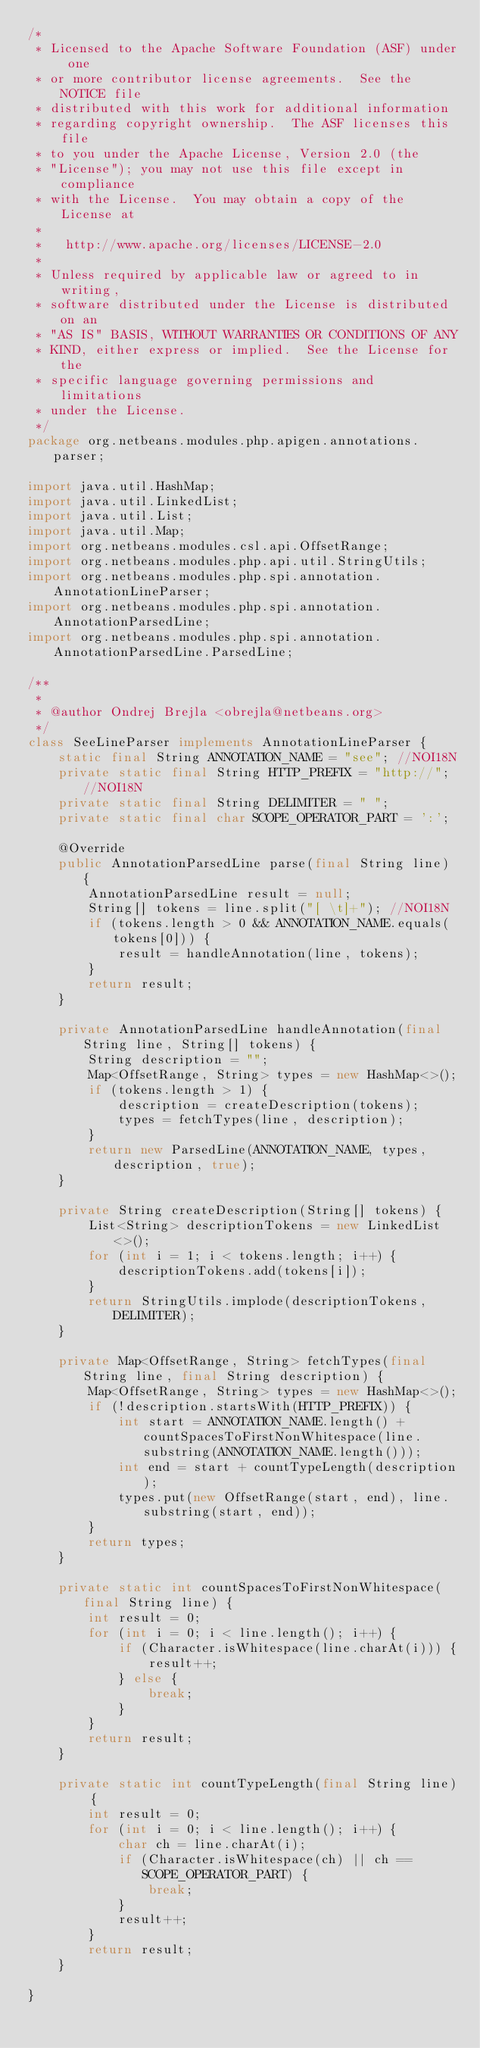<code> <loc_0><loc_0><loc_500><loc_500><_Java_>/*
 * Licensed to the Apache Software Foundation (ASF) under one
 * or more contributor license agreements.  See the NOTICE file
 * distributed with this work for additional information
 * regarding copyright ownership.  The ASF licenses this file
 * to you under the Apache License, Version 2.0 (the
 * "License"); you may not use this file except in compliance
 * with the License.  You may obtain a copy of the License at
 *
 *   http://www.apache.org/licenses/LICENSE-2.0
 *
 * Unless required by applicable law or agreed to in writing,
 * software distributed under the License is distributed on an
 * "AS IS" BASIS, WITHOUT WARRANTIES OR CONDITIONS OF ANY
 * KIND, either express or implied.  See the License for the
 * specific language governing permissions and limitations
 * under the License.
 */
package org.netbeans.modules.php.apigen.annotations.parser;

import java.util.HashMap;
import java.util.LinkedList;
import java.util.List;
import java.util.Map;
import org.netbeans.modules.csl.api.OffsetRange;
import org.netbeans.modules.php.api.util.StringUtils;
import org.netbeans.modules.php.spi.annotation.AnnotationLineParser;
import org.netbeans.modules.php.spi.annotation.AnnotationParsedLine;
import org.netbeans.modules.php.spi.annotation.AnnotationParsedLine.ParsedLine;

/**
 *
 * @author Ondrej Brejla <obrejla@netbeans.org>
 */
class SeeLineParser implements AnnotationLineParser {
    static final String ANNOTATION_NAME = "see"; //NOI18N
    private static final String HTTP_PREFIX = "http://"; //NOI18N
    private static final String DELIMITER = " ";
    private static final char SCOPE_OPERATOR_PART = ':';

    @Override
    public AnnotationParsedLine parse(final String line) {
        AnnotationParsedLine result = null;
        String[] tokens = line.split("[ \t]+"); //NOI18N
        if (tokens.length > 0 && ANNOTATION_NAME.equals(tokens[0])) {
            result = handleAnnotation(line, tokens);
        }
        return result;
    }

    private AnnotationParsedLine handleAnnotation(final String line, String[] tokens) {
        String description = "";
        Map<OffsetRange, String> types = new HashMap<>();
        if (tokens.length > 1) {
            description = createDescription(tokens);
            types = fetchTypes(line, description);
        }
        return new ParsedLine(ANNOTATION_NAME, types, description, true);
    }

    private String createDescription(String[] tokens) {
        List<String> descriptionTokens = new LinkedList<>();
        for (int i = 1; i < tokens.length; i++) {
            descriptionTokens.add(tokens[i]);
        }
        return StringUtils.implode(descriptionTokens, DELIMITER);
    }

    private Map<OffsetRange, String> fetchTypes(final String line, final String description) {
        Map<OffsetRange, String> types = new HashMap<>();
        if (!description.startsWith(HTTP_PREFIX)) {
            int start = ANNOTATION_NAME.length() + countSpacesToFirstNonWhitespace(line.substring(ANNOTATION_NAME.length()));
            int end = start + countTypeLength(description);
            types.put(new OffsetRange(start, end), line.substring(start, end));
        }
        return types;
    }

    private static int countSpacesToFirstNonWhitespace(final String line) {
        int result = 0;
        for (int i = 0; i < line.length(); i++) {
            if (Character.isWhitespace(line.charAt(i))) {
                result++;
            } else {
                break;
            }
        }
        return result;
    }

    private static int countTypeLength(final String line) {
        int result = 0;
        for (int i = 0; i < line.length(); i++) {
            char ch = line.charAt(i);
            if (Character.isWhitespace(ch) || ch == SCOPE_OPERATOR_PART) {
                break;
            }
            result++;
        }
        return result;
    }

}
</code> 